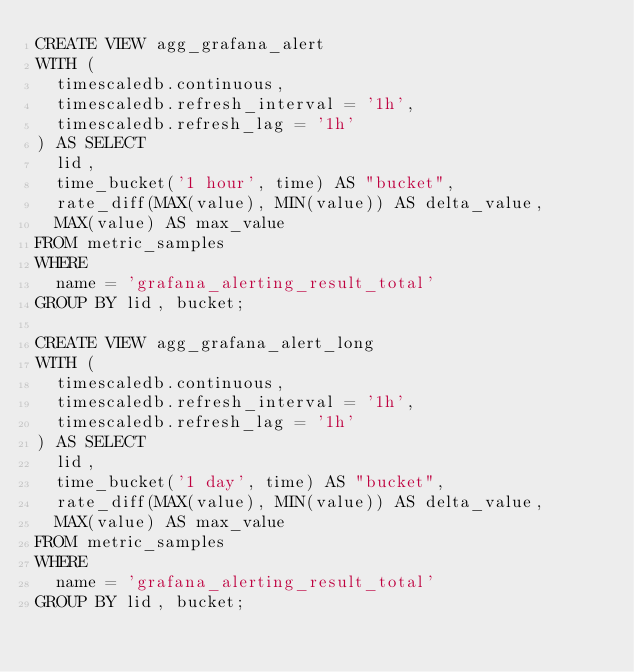<code> <loc_0><loc_0><loc_500><loc_500><_SQL_>CREATE VIEW agg_grafana_alert
WITH (
  timescaledb.continuous,
  timescaledb.refresh_interval = '1h',
  timescaledb.refresh_lag = '1h'
) AS SELECT
  lid,
  time_bucket('1 hour', time) AS "bucket",
  rate_diff(MAX(value), MIN(value)) AS delta_value,
  MAX(value) AS max_value
FROM metric_samples
WHERE
  name = 'grafana_alerting_result_total'
GROUP BY lid, bucket;

CREATE VIEW agg_grafana_alert_long
WITH (
  timescaledb.continuous,
  timescaledb.refresh_interval = '1h',
  timescaledb.refresh_lag = '1h'
) AS SELECT
  lid,
  time_bucket('1 day', time) AS "bucket",
  rate_diff(MAX(value), MIN(value)) AS delta_value,
  MAX(value) AS max_value
FROM metric_samples
WHERE
  name = 'grafana_alerting_result_total'
GROUP BY lid, bucket;

</code> 